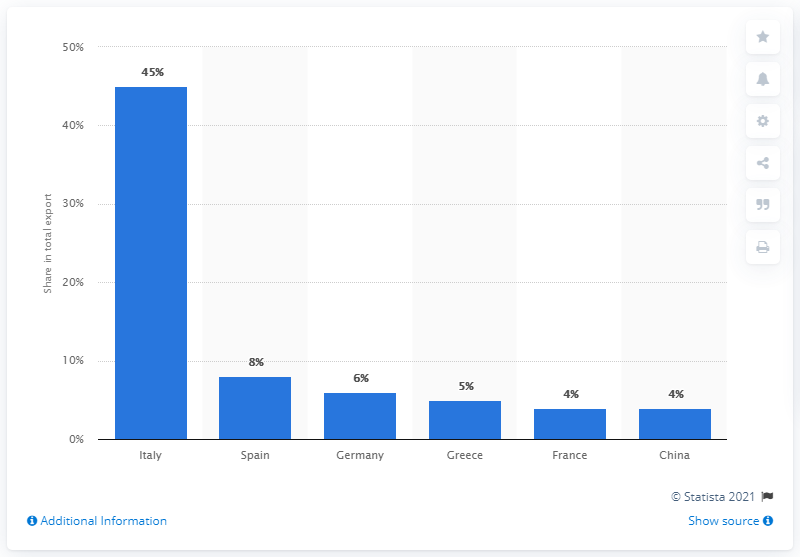Give some essential details in this illustration. Albania's most important export partner in 2019 was Italy, as the country's exports to Italy accounted for the largest share of its total exports. 